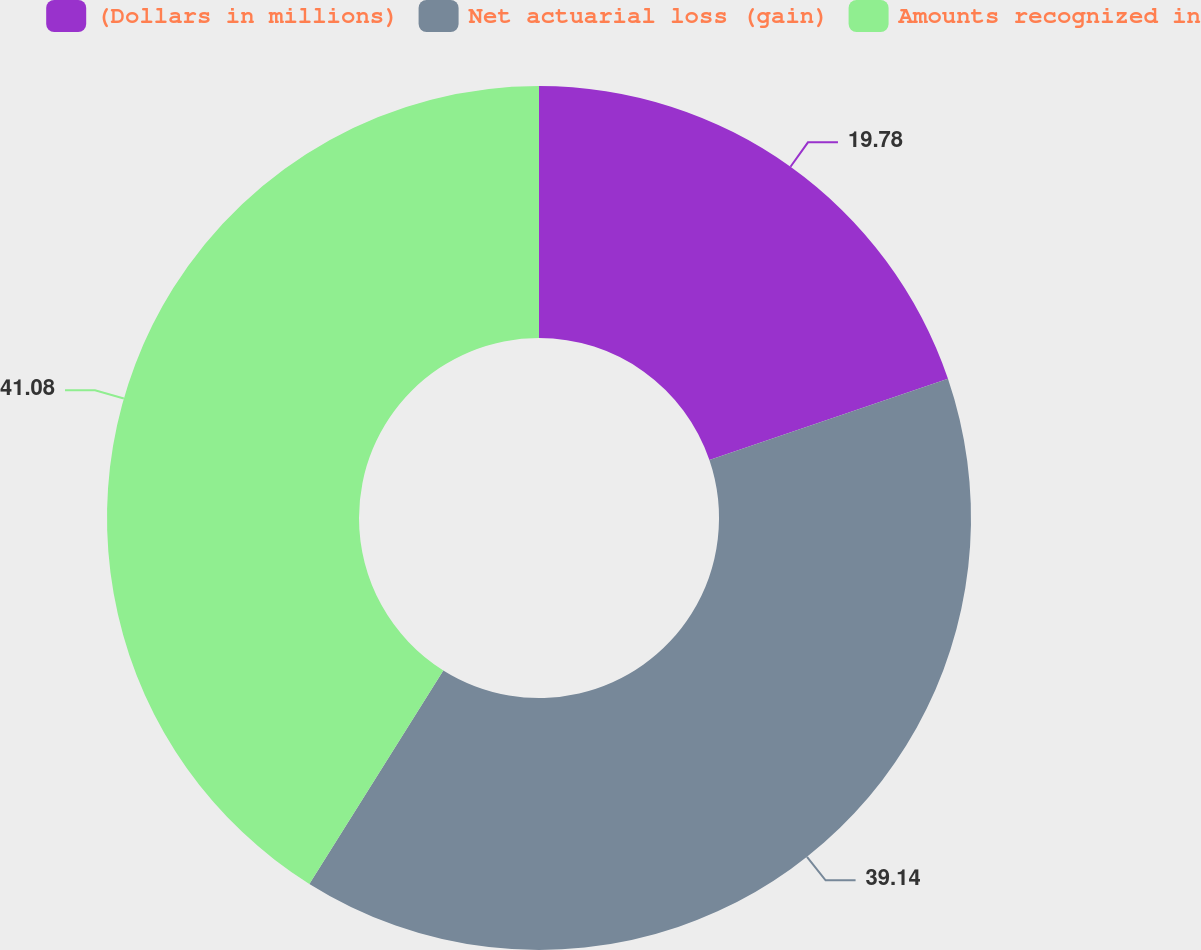Convert chart. <chart><loc_0><loc_0><loc_500><loc_500><pie_chart><fcel>(Dollars in millions)<fcel>Net actuarial loss (gain)<fcel>Amounts recognized in<nl><fcel>19.78%<fcel>39.14%<fcel>41.08%<nl></chart> 